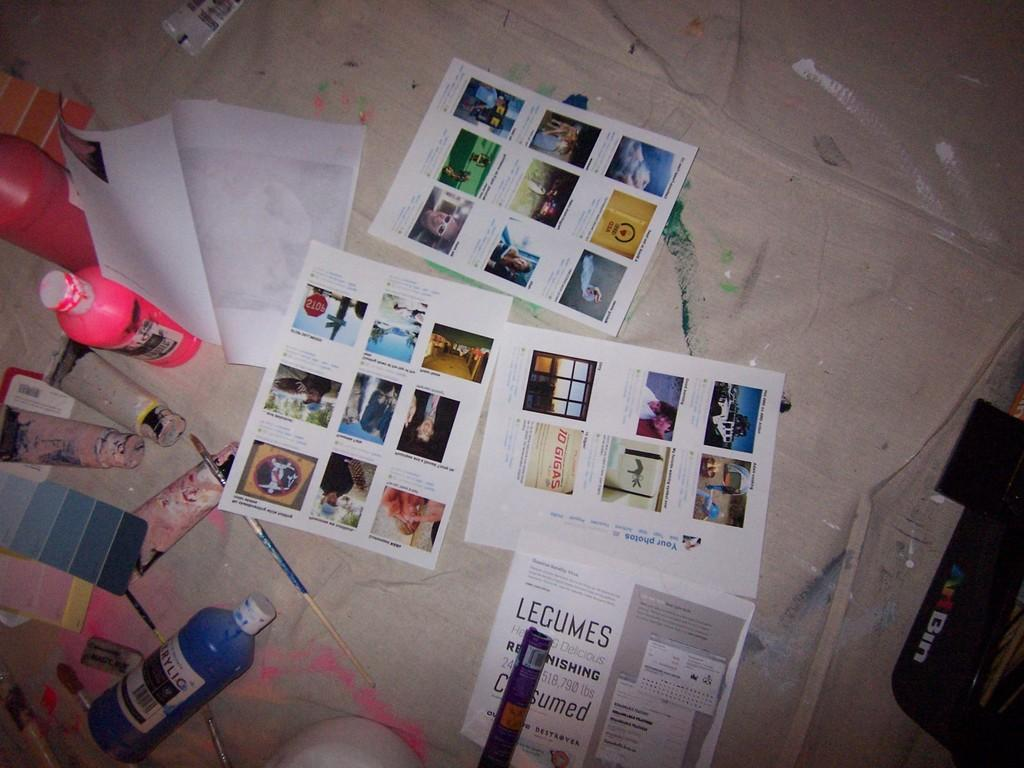<image>
Write a terse but informative summary of the picture. an art table with pictures and signs saying Legumes on it 